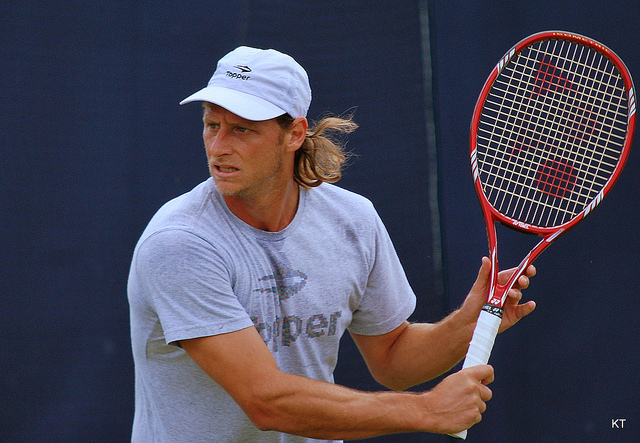<image>What brand of racket is he using? It is unclear what brand of racket he is using. It can be 'new balance', 'wilson', 'tennis' or 'topper'. What brand of racket is he using? I am not sure what brand of racket he is using. It can be either 'new balance', 'wilson', 'tennis', 'topper' or unknown. 